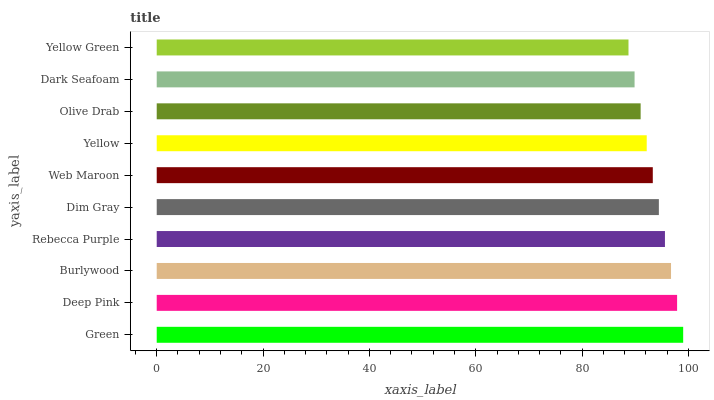Is Yellow Green the minimum?
Answer yes or no. Yes. Is Green the maximum?
Answer yes or no. Yes. Is Deep Pink the minimum?
Answer yes or no. No. Is Deep Pink the maximum?
Answer yes or no. No. Is Green greater than Deep Pink?
Answer yes or no. Yes. Is Deep Pink less than Green?
Answer yes or no. Yes. Is Deep Pink greater than Green?
Answer yes or no. No. Is Green less than Deep Pink?
Answer yes or no. No. Is Dim Gray the high median?
Answer yes or no. Yes. Is Web Maroon the low median?
Answer yes or no. Yes. Is Web Maroon the high median?
Answer yes or no. No. Is Dark Seafoam the low median?
Answer yes or no. No. 